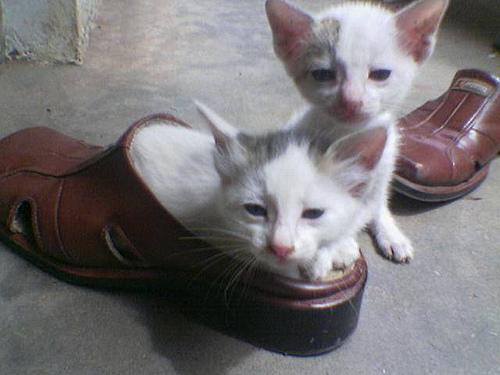How many kittens are there?
Give a very brief answer. 2. How many zebras are here?
Give a very brief answer. 0. 